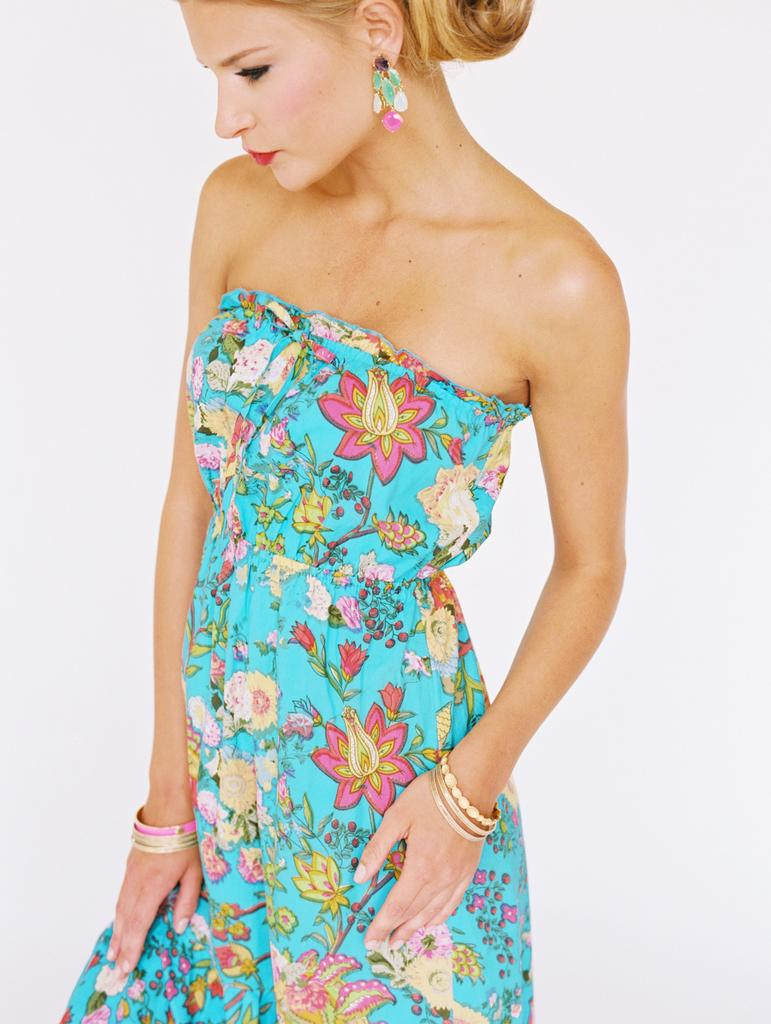Who is present in the image? There is a woman in the image. What accessories is the woman wearing? The woman is wearing earrings and bangles. What type of clothing is the woman wearing? The woman is wearing a dress. What can be seen in the background of the image? There is brightness visible in the background of the image. What type of quill is the woman holding in the image? There is no quill present in the image. What is the woman using to support the rod in the image? There is no rod present in the image. 